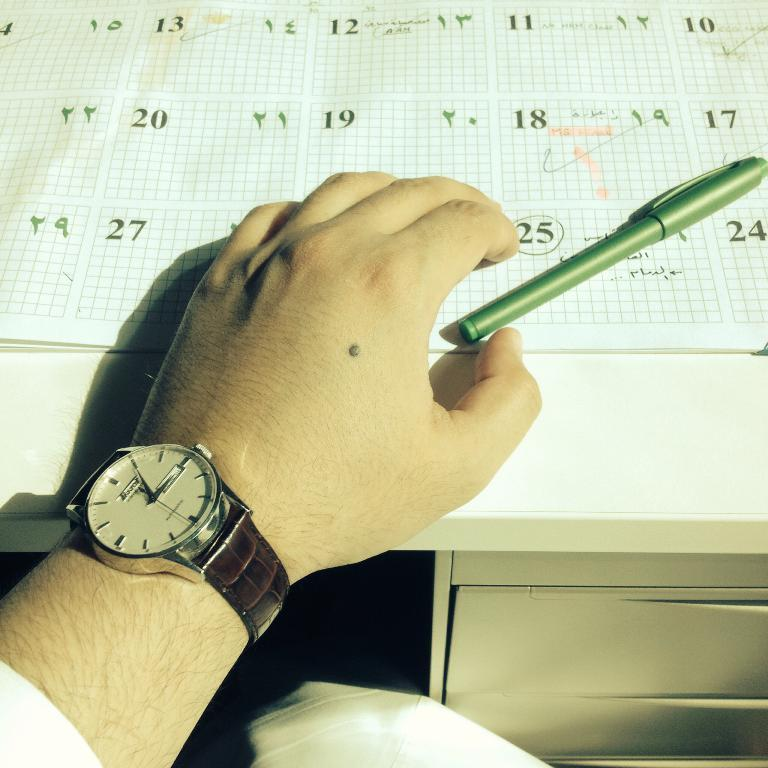What piece of furniture is present in the image? There is a table in the image. What objects are on the table? There is a pen and a book on the table. Can you describe any body parts visible in the image? A person's hand wearing a wrist watch is visible on the table. How many geese are flying over the table in the image? There are no geese present in the image. What is the father doing in the image? The facts provided do not mention a father or any specific actions being performed in the image. 